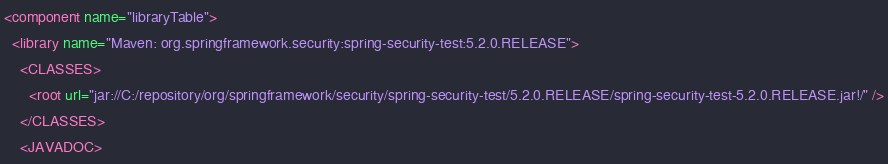Convert code to text. <code><loc_0><loc_0><loc_500><loc_500><_XML_><component name="libraryTable">
  <library name="Maven: org.springframework.security:spring-security-test:5.2.0.RELEASE">
    <CLASSES>
      <root url="jar://C:/repository/org/springframework/security/spring-security-test/5.2.0.RELEASE/spring-security-test-5.2.0.RELEASE.jar!/" />
    </CLASSES>
    <JAVADOC></code> 